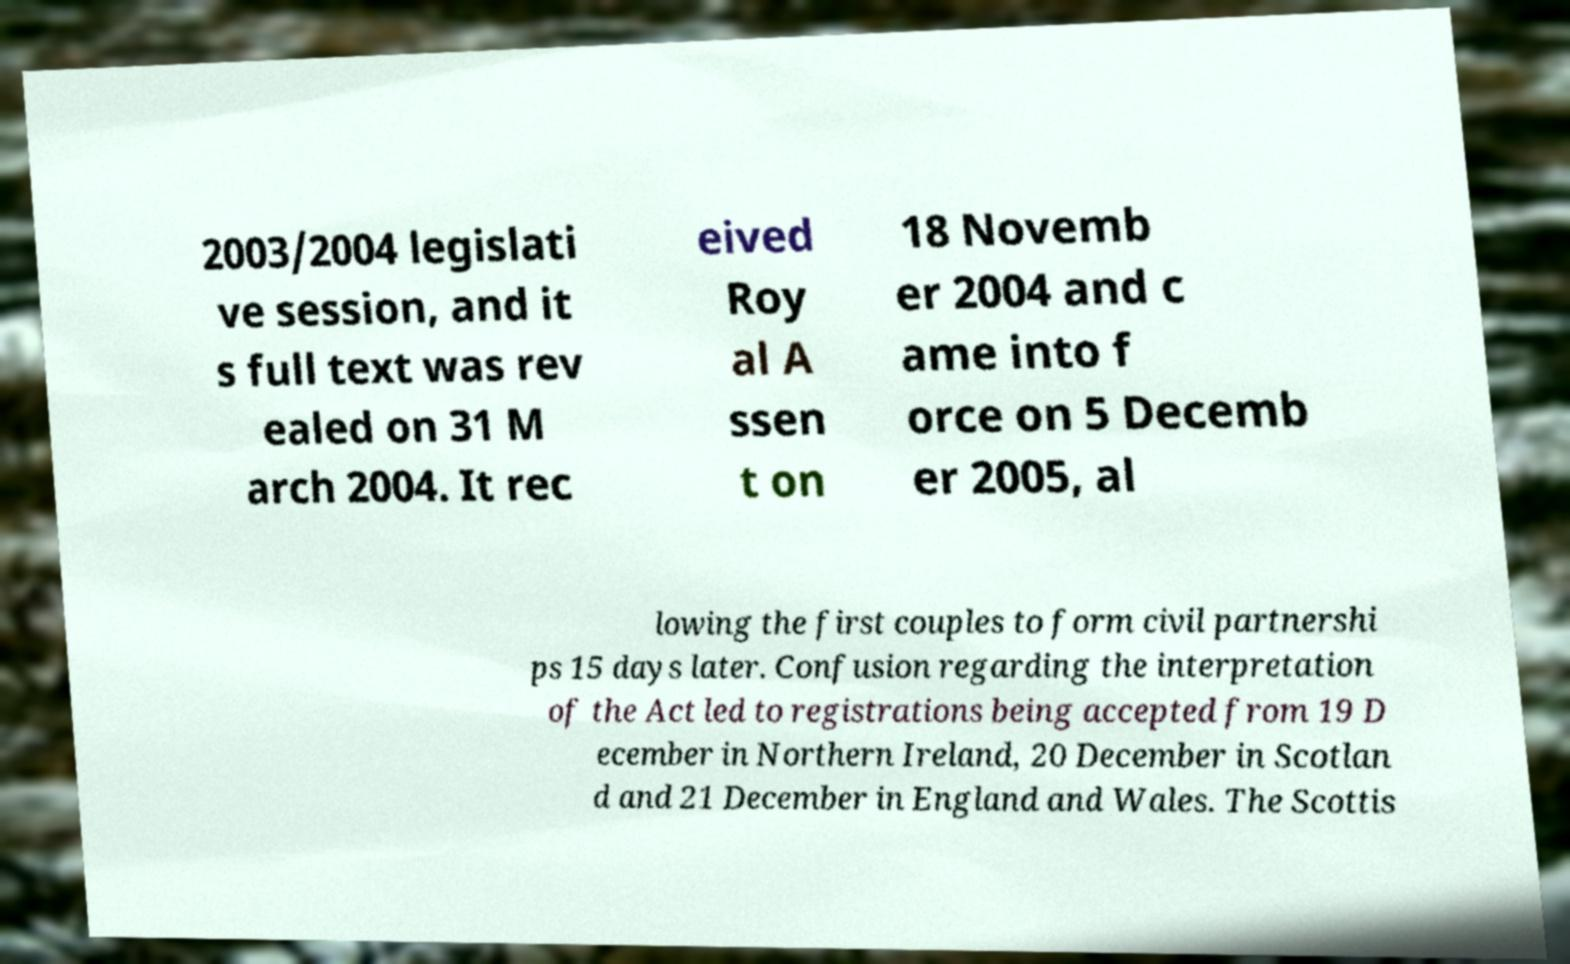For documentation purposes, I need the text within this image transcribed. Could you provide that? 2003/2004 legislati ve session, and it s full text was rev ealed on 31 M arch 2004. It rec eived Roy al A ssen t on 18 Novemb er 2004 and c ame into f orce on 5 Decemb er 2005, al lowing the first couples to form civil partnershi ps 15 days later. Confusion regarding the interpretation of the Act led to registrations being accepted from 19 D ecember in Northern Ireland, 20 December in Scotlan d and 21 December in England and Wales. The Scottis 